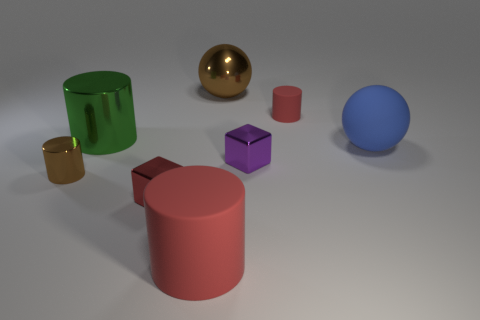Subtract 1 cylinders. How many cylinders are left? 3 Add 1 large purple metal things. How many objects exist? 9 Subtract all balls. How many objects are left? 6 Add 7 purple metal cubes. How many purple metal cubes exist? 8 Subtract 1 brown balls. How many objects are left? 7 Subtract all small brown cubes. Subtract all small objects. How many objects are left? 4 Add 8 small brown objects. How many small brown objects are left? 9 